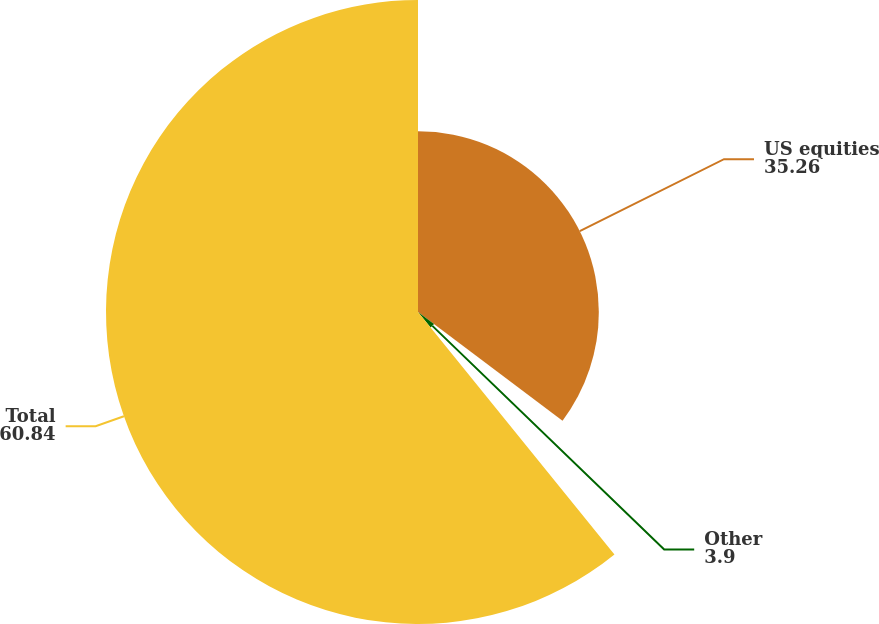Convert chart. <chart><loc_0><loc_0><loc_500><loc_500><pie_chart><fcel>US equities<fcel>Other<fcel>Total<nl><fcel>35.26%<fcel>3.9%<fcel>60.84%<nl></chart> 